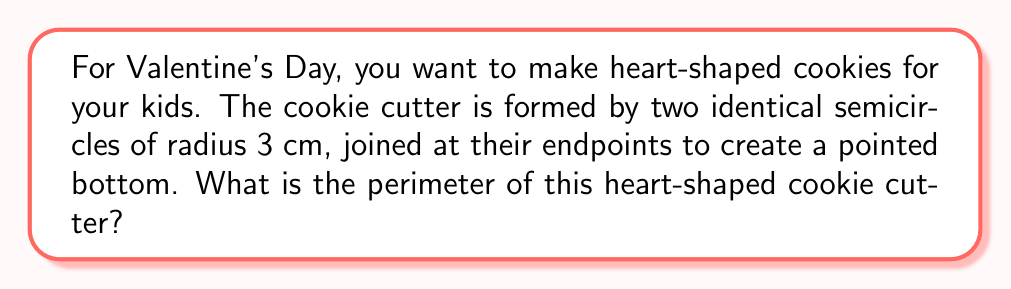Give your solution to this math problem. Let's approach this step-by-step:

1) The heart shape is composed of two semicircles. Each semicircle has a radius of 3 cm.

2) The perimeter of the heart consists of two parts:
   a) The curved part (two semicircles)
   b) The pointed bottom (where the semicircles meet)

3) For the curved part:
   - The circumference of a full circle is $2\pi r$
   - Each semicircle is half of this, so its length is $\pi r$
   - We have two semicircles, so the total curved length is $2\pi r$
   - With $r = 3$ cm, this becomes $2\pi(3) = 6\pi$ cm

4) For the pointed bottom:
   - This is formed by two radii meeting at a point
   - Each radius is 3 cm
   - So the total straight part is $3 + 3 = 6$ cm

5) The total perimeter is the sum of the curved part and the straight part:
   $6\pi + 6$ cm

6) If we want to calculate this numerically:
   $6\pi + 6 \approx 18.85 + 6 = 24.85$ cm

Therefore, the perimeter of the heart-shaped cookie cutter is $6\pi + 6$ cm or approximately 24.85 cm.
Answer: $6\pi + 6$ cm 